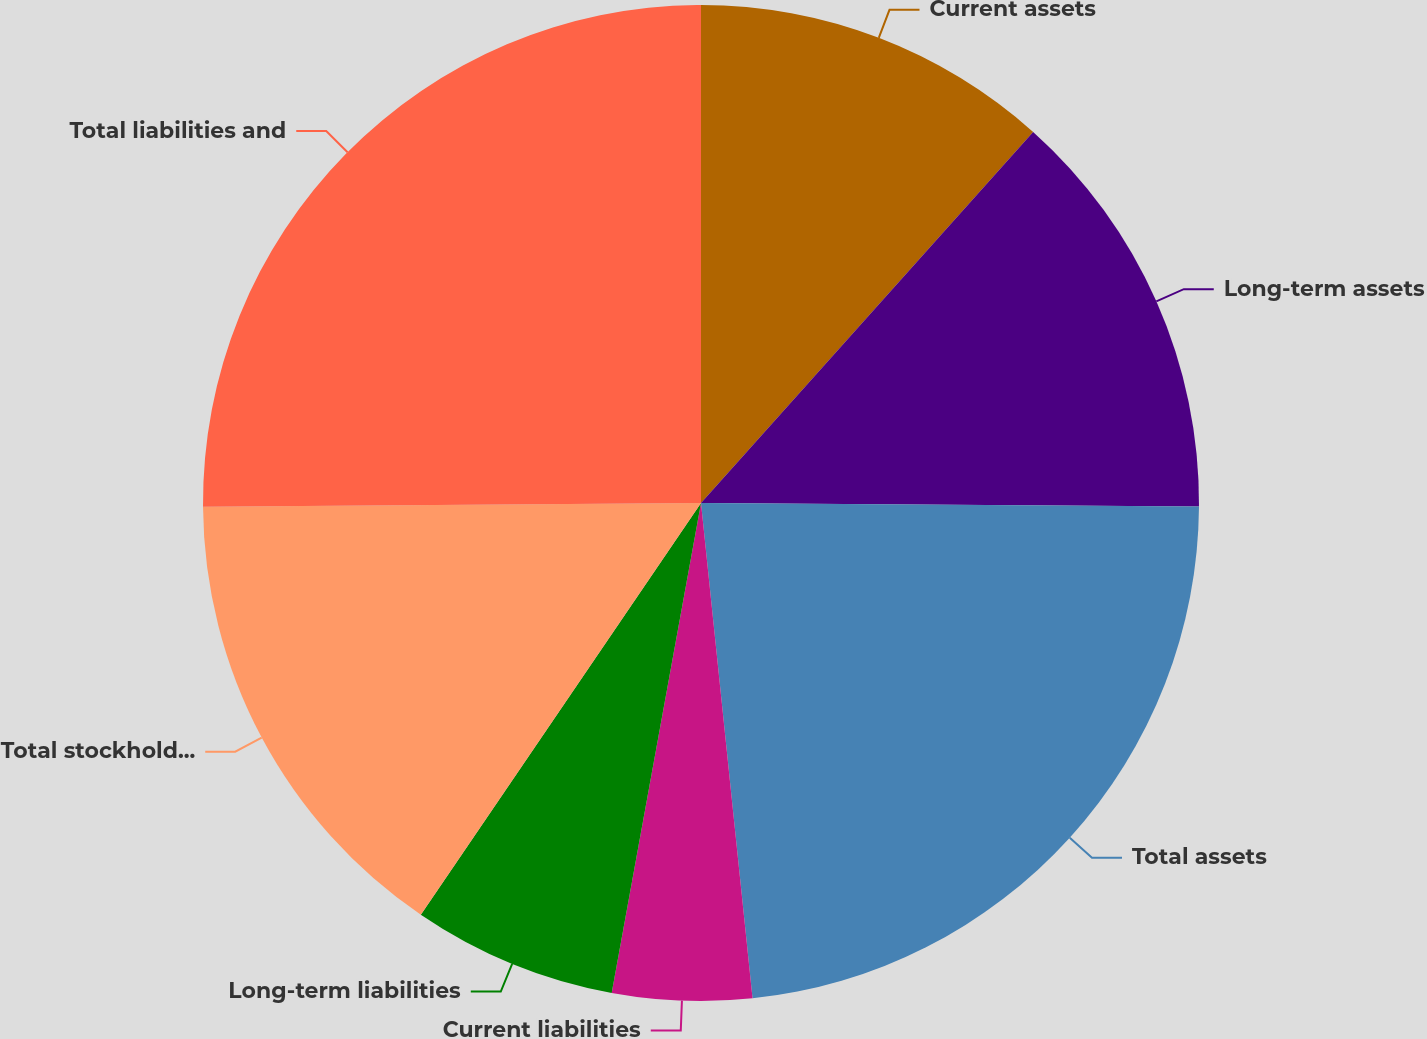Convert chart. <chart><loc_0><loc_0><loc_500><loc_500><pie_chart><fcel>Current assets<fcel>Long-term assets<fcel>Total assets<fcel>Current liabilities<fcel>Long-term liabilities<fcel>Total stockholders' equity<fcel>Total liabilities and<nl><fcel>11.62%<fcel>13.49%<fcel>23.24%<fcel>4.52%<fcel>6.64%<fcel>15.37%<fcel>25.12%<nl></chart> 